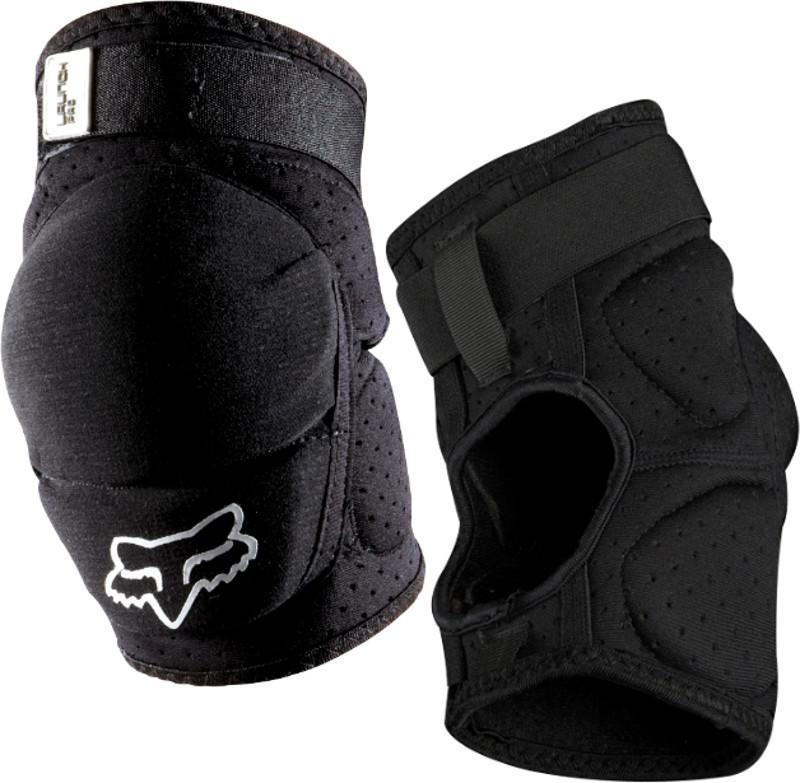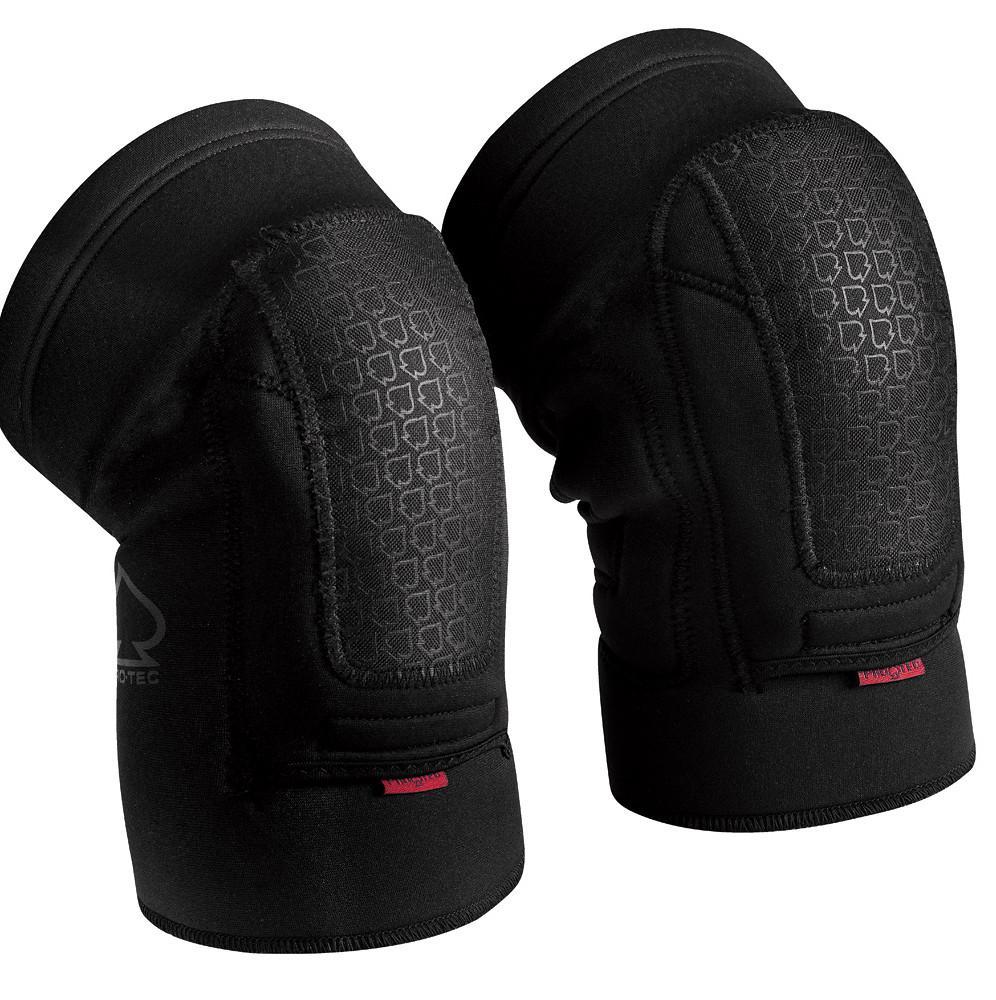The first image is the image on the left, the second image is the image on the right. For the images displayed, is the sentence "The right image shows a right-turned pair of pads, and the left image shows front and back views of a pair of pads." factually correct? Answer yes or no. Yes. The first image is the image on the left, the second image is the image on the right. For the images shown, is this caption "One of the knee pads has a white logo on the bottom" true? Answer yes or no. Yes. 